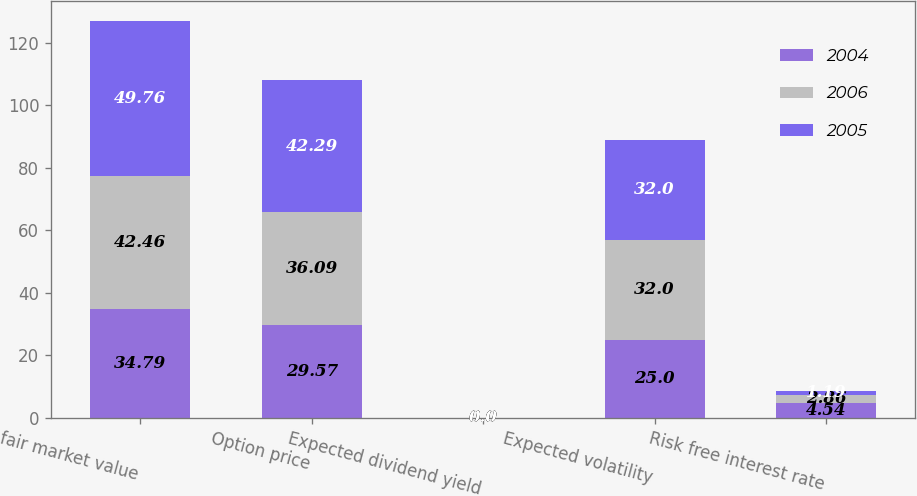<chart> <loc_0><loc_0><loc_500><loc_500><stacked_bar_chart><ecel><fcel>fair market value<fcel>Option price<fcel>Expected dividend yield<fcel>Expected volatility<fcel>Risk free interest rate<nl><fcel>2004<fcel>34.79<fcel>29.57<fcel>0<fcel>25<fcel>4.54<nl><fcel>2006<fcel>42.46<fcel>36.09<fcel>0<fcel>32<fcel>2.86<nl><fcel>2005<fcel>49.76<fcel>42.29<fcel>0<fcel>32<fcel>1.19<nl></chart> 